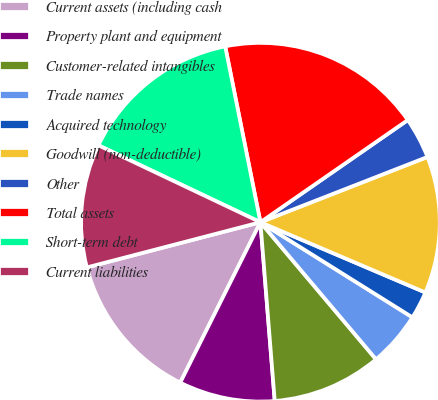Convert chart. <chart><loc_0><loc_0><loc_500><loc_500><pie_chart><fcel>Current assets (including cash<fcel>Property plant and equipment<fcel>Customer-related intangibles<fcel>Trade names<fcel>Acquired technology<fcel>Goodwill (non-deductible)<fcel>Other<fcel>Total assets<fcel>Short-term debt<fcel>Current liabilities<nl><fcel>13.57%<fcel>8.65%<fcel>9.88%<fcel>4.95%<fcel>2.49%<fcel>12.34%<fcel>3.72%<fcel>18.5%<fcel>14.8%<fcel>11.11%<nl></chart> 